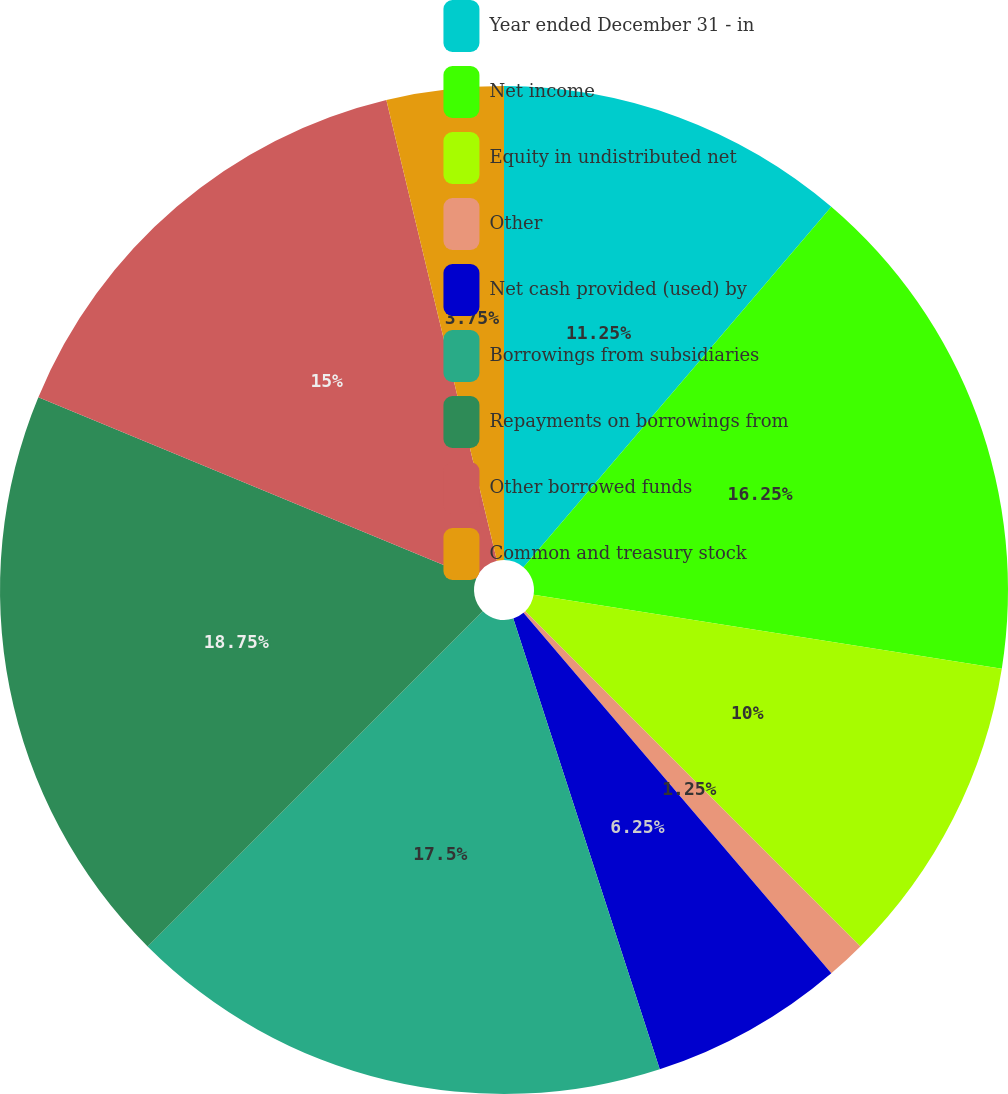Convert chart. <chart><loc_0><loc_0><loc_500><loc_500><pie_chart><fcel>Year ended December 31 - in<fcel>Net income<fcel>Equity in undistributed net<fcel>Other<fcel>Net cash provided (used) by<fcel>Borrowings from subsidiaries<fcel>Repayments on borrowings from<fcel>Other borrowed funds<fcel>Common and treasury stock<nl><fcel>11.25%<fcel>16.25%<fcel>10.0%<fcel>1.25%<fcel>6.25%<fcel>17.5%<fcel>18.75%<fcel>15.0%<fcel>3.75%<nl></chart> 